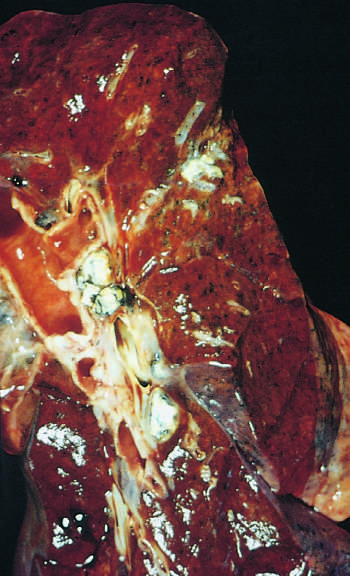where are hilar lymph nodes with caseation seen?
Answer the question using a single word or phrase. On the left 